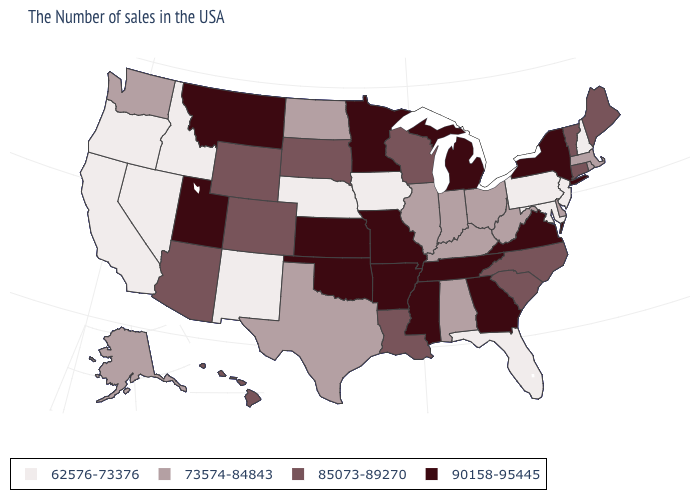Is the legend a continuous bar?
Keep it brief. No. What is the value of New York?
Quick response, please. 90158-95445. Which states hav the highest value in the West?
Be succinct. Utah, Montana. What is the value of Virginia?
Write a very short answer. 90158-95445. Does New Jersey have the lowest value in the Northeast?
Give a very brief answer. Yes. What is the highest value in the USA?
Write a very short answer. 90158-95445. What is the value of Kentucky?
Quick response, please. 73574-84843. Name the states that have a value in the range 62576-73376?
Answer briefly. New Hampshire, New Jersey, Maryland, Pennsylvania, Florida, Iowa, Nebraska, New Mexico, Idaho, Nevada, California, Oregon. Which states have the lowest value in the South?
Short answer required. Maryland, Florida. What is the value of California?
Short answer required. 62576-73376. Does North Carolina have the lowest value in the USA?
Write a very short answer. No. What is the value of Wisconsin?
Be succinct. 85073-89270. Which states have the lowest value in the MidWest?
Answer briefly. Iowa, Nebraska. What is the value of North Carolina?
Write a very short answer. 85073-89270. What is the value of Oregon?
Keep it brief. 62576-73376. 